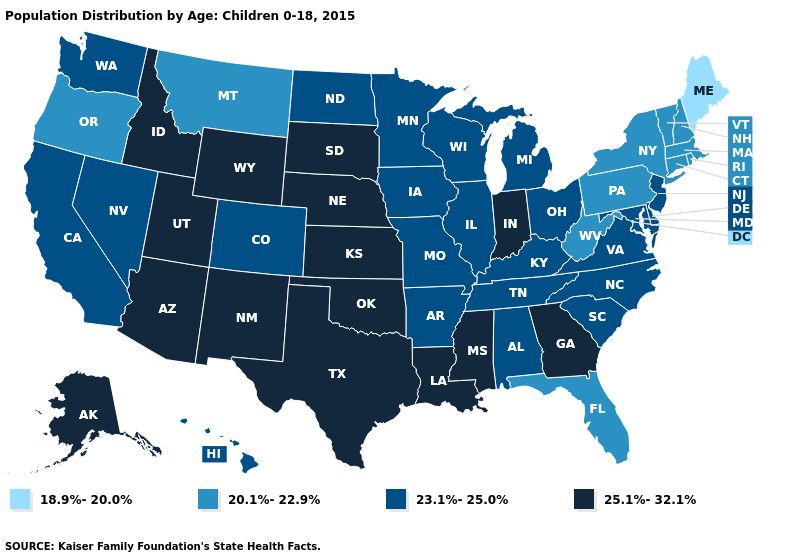Does the first symbol in the legend represent the smallest category?
Quick response, please. Yes. What is the value of South Carolina?
Short answer required. 23.1%-25.0%. Name the states that have a value in the range 25.1%-32.1%?
Give a very brief answer. Alaska, Arizona, Georgia, Idaho, Indiana, Kansas, Louisiana, Mississippi, Nebraska, New Mexico, Oklahoma, South Dakota, Texas, Utah, Wyoming. Which states hav the highest value in the South?
Be succinct. Georgia, Louisiana, Mississippi, Oklahoma, Texas. What is the lowest value in the Northeast?
Answer briefly. 18.9%-20.0%. Which states have the highest value in the USA?
Give a very brief answer. Alaska, Arizona, Georgia, Idaho, Indiana, Kansas, Louisiana, Mississippi, Nebraska, New Mexico, Oklahoma, South Dakota, Texas, Utah, Wyoming. Does Illinois have the same value as New Hampshire?
Be succinct. No. Does Tennessee have the same value as Florida?
Give a very brief answer. No. What is the highest value in the USA?
Concise answer only. 25.1%-32.1%. Which states have the lowest value in the USA?
Concise answer only. Maine. Does Washington have a higher value than New York?
Write a very short answer. Yes. What is the value of Tennessee?
Be succinct. 23.1%-25.0%. What is the highest value in the USA?
Write a very short answer. 25.1%-32.1%. What is the lowest value in the West?
Keep it brief. 20.1%-22.9%. What is the value of Kansas?
Concise answer only. 25.1%-32.1%. 